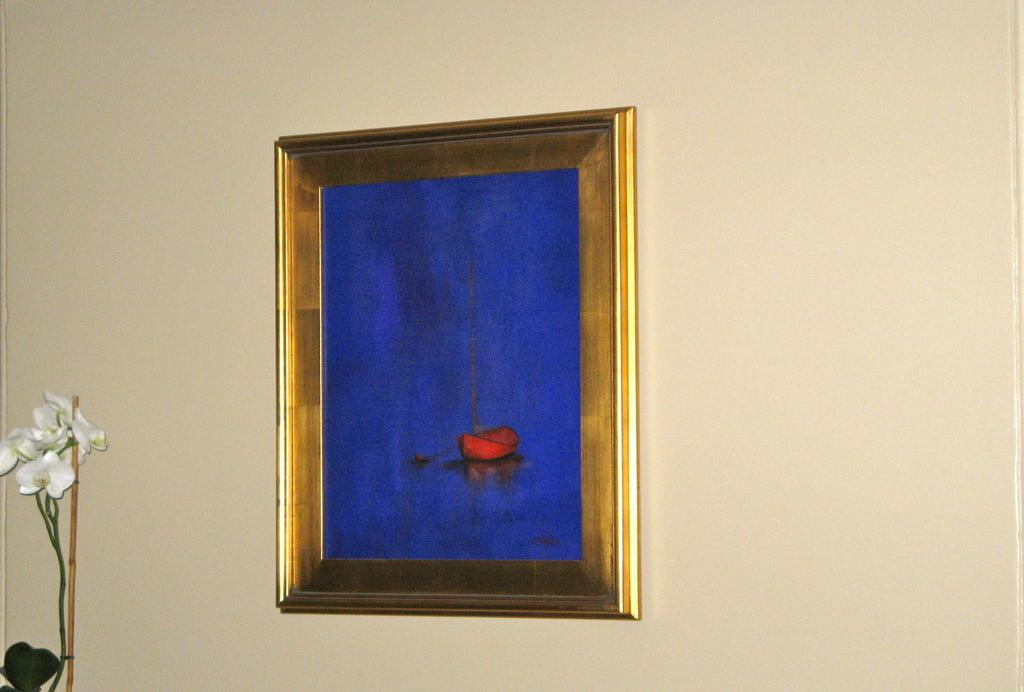What is hanging on the wall in the image? There is a photo frame on the wall. What is depicted in the photo frame? The photo frame contains a picture of a boat. What other elements can be seen in the image? There are flowers in the bottom left of the image, presumably belonging to a plant. What type of religious symbol can be seen in the image? There is no religious symbol present in the image. Can you describe the pig that is visible in the image? There is no pig present in the image. 